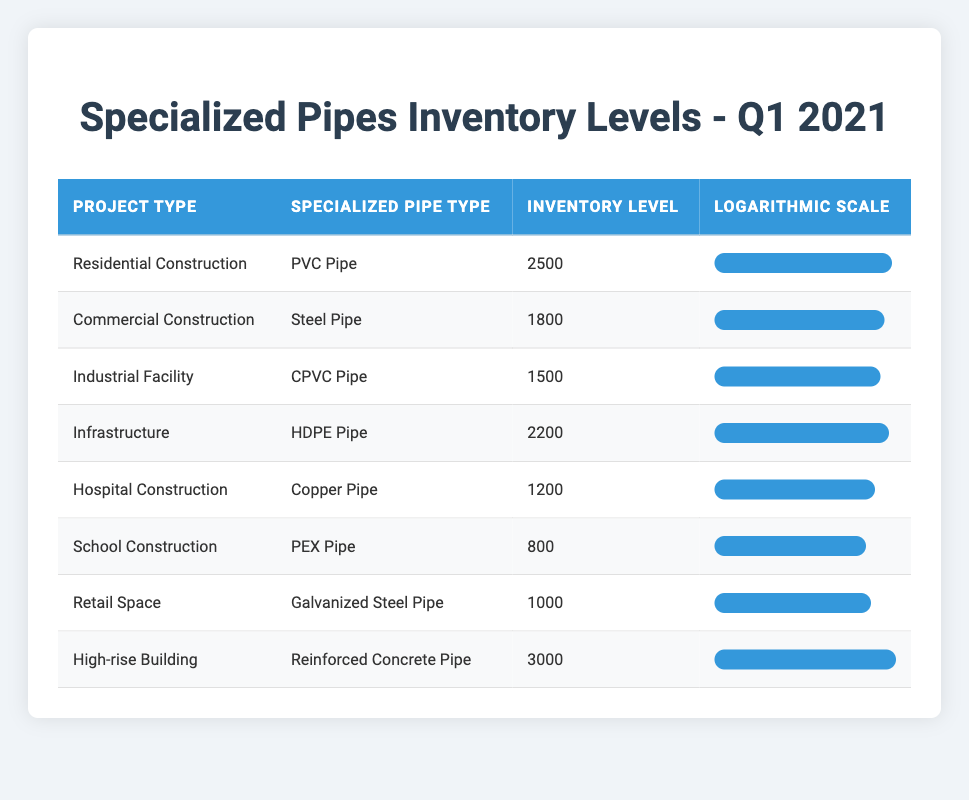What is the inventory level for PVC Pipe in Residential Construction? The table lists the inventory levels for various specialized pipes along with their project types. For Residential Construction, the specialized pipe is PVC Pipe and its inventory level is directly provided as 2500.
Answer: 2500 Which project type has the highest inventory level? By reviewing the inventory levels listed in the table, High-rise Building has the highest inventory level of 3000.
Answer: High-rise Building What is the total inventory level of all specialized pipes? To find the total inventory level, add the inventory values: 2500 + 1800 + 1500 + 2200 + 1200 + 800 + 1000 + 3000 = 15000.
Answer: 15000 How many project types have an inventory level below 1000? Checking the inventory levels provided, only School Construction with 800 has an inventory level below 1000. Thus, the count is 1.
Answer: 1 Is it true that the inventory level for Steel Pipe in Commercial Construction is greater than 2000? The table indicates that the inventory level for Steel Pipe in Commercial Construction is 1800, which is not greater than 2000, making the statement false.
Answer: No Which specialized pipe type has the lowest inventory level? The table displays various inventory levels, and upon finding the minimum, it shows that School Construction with PEX Pipe has the lowest inventory level of 800.
Answer: PEX Pipe How much more inventory level does HDPE Pipe have compared to Copper Pipe? HDPE Pipe has an inventory level of 2200 while Copper Pipe shows an inventory level of 1200. Calculate the difference: 2200 - 1200 = 1000.
Answer: 1000 What percentage of the total inventory does the inventory level for Industrial Facility (CPVC Pipe) represent? The total inventory level is 15000 and the level for CPVC Pipe is 1500. To get the percentage: (1500 / 15000) * 100 = 10%.
Answer: 10% 